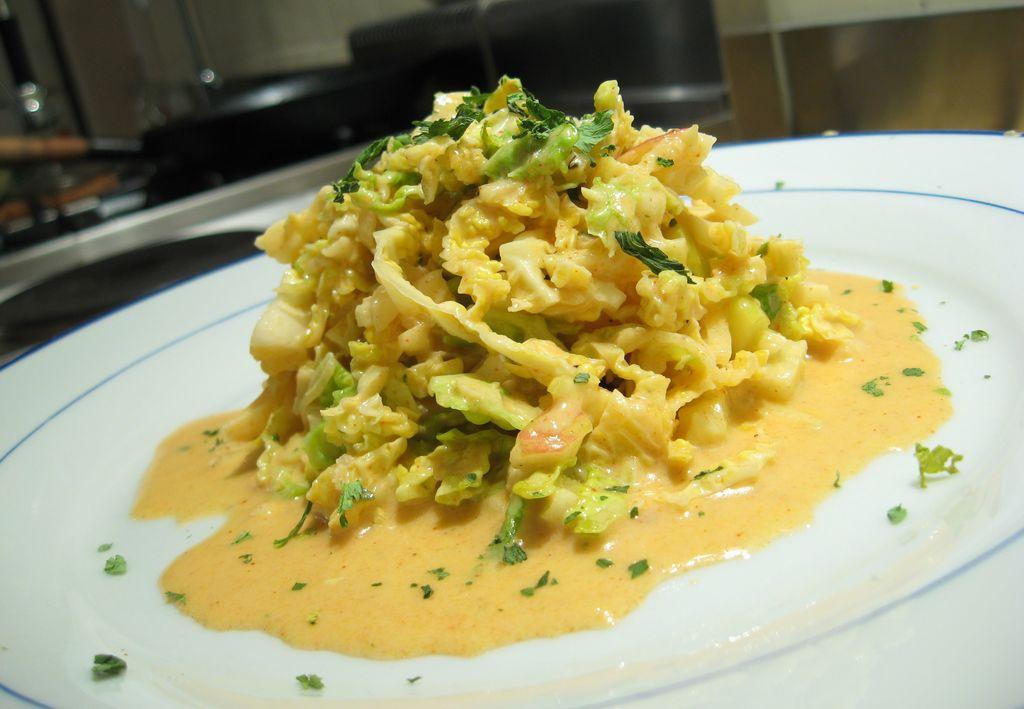What is located in the foreground of the image? There is a plate in the foreground of the image. What is on the plate? There is food on the plate. What can be seen in the background of the image? There are objects visible in the background of the image. What type of fear can be seen on the faces of the frogs in the image? There are no frogs present in the image, so it is not possible to determine if they are experiencing any fear. 